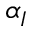<formula> <loc_0><loc_0><loc_500><loc_500>\alpha _ { I }</formula> 